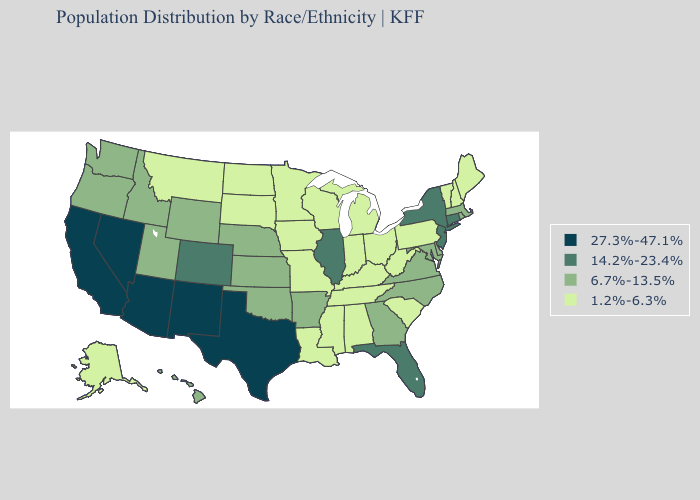Does Alaska have a lower value than Michigan?
Quick response, please. No. Name the states that have a value in the range 6.7%-13.5%?
Keep it brief. Arkansas, Delaware, Georgia, Hawaii, Idaho, Kansas, Maryland, Massachusetts, Nebraska, North Carolina, Oklahoma, Oregon, Rhode Island, Utah, Virginia, Washington, Wyoming. Among the states that border Oregon , does Nevada have the highest value?
Answer briefly. Yes. Which states have the highest value in the USA?
Write a very short answer. Arizona, California, Nevada, New Mexico, Texas. Does Wisconsin have the highest value in the MidWest?
Answer briefly. No. What is the lowest value in the MidWest?
Keep it brief. 1.2%-6.3%. Does the map have missing data?
Answer briefly. No. How many symbols are there in the legend?
Answer briefly. 4. Is the legend a continuous bar?
Concise answer only. No. Does Pennsylvania have the highest value in the Northeast?
Be succinct. No. Which states have the lowest value in the USA?
Short answer required. Alabama, Alaska, Indiana, Iowa, Kentucky, Louisiana, Maine, Michigan, Minnesota, Mississippi, Missouri, Montana, New Hampshire, North Dakota, Ohio, Pennsylvania, South Carolina, South Dakota, Tennessee, Vermont, West Virginia, Wisconsin. Name the states that have a value in the range 27.3%-47.1%?
Short answer required. Arizona, California, Nevada, New Mexico, Texas. Name the states that have a value in the range 27.3%-47.1%?
Answer briefly. Arizona, California, Nevada, New Mexico, Texas. Does Kansas have the lowest value in the MidWest?
Give a very brief answer. No. Which states have the lowest value in the South?
Short answer required. Alabama, Kentucky, Louisiana, Mississippi, South Carolina, Tennessee, West Virginia. 